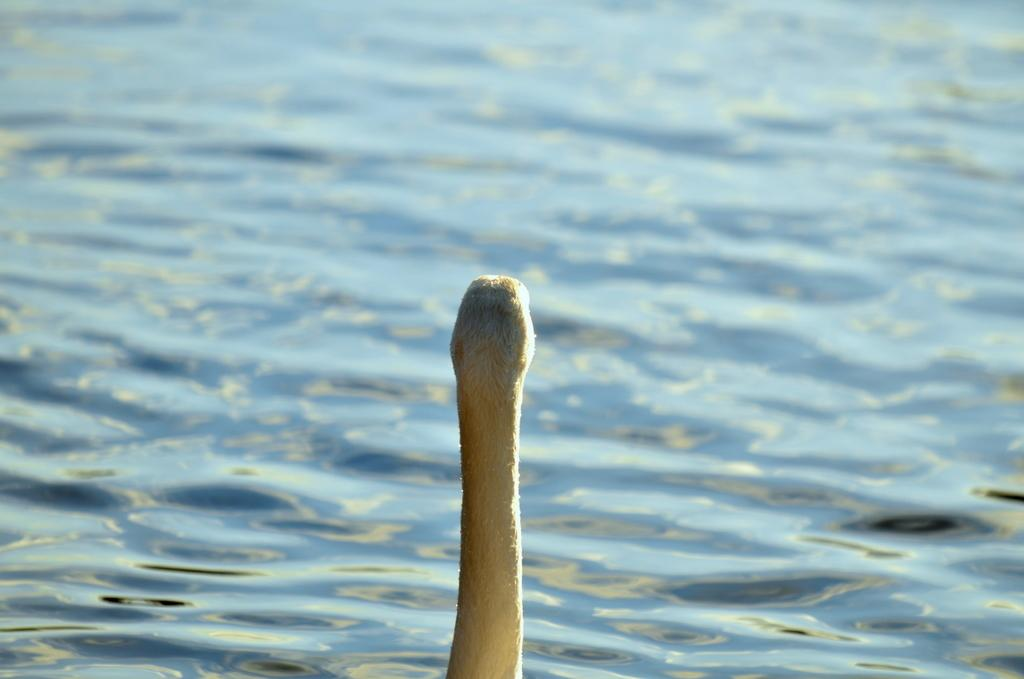What is the main subject of the image? The main subject of the image is a swan's head. Where is the swan's head located in the image? The swan's head is in the front of the image. What can be seen in the background of the image? There is water visible in the background of the image. How does the swan's head compare to the size of the land in the image? There is no land present in the image, only water in the background. The swan's head is in the front of the image, and it is not being compared to any land. 